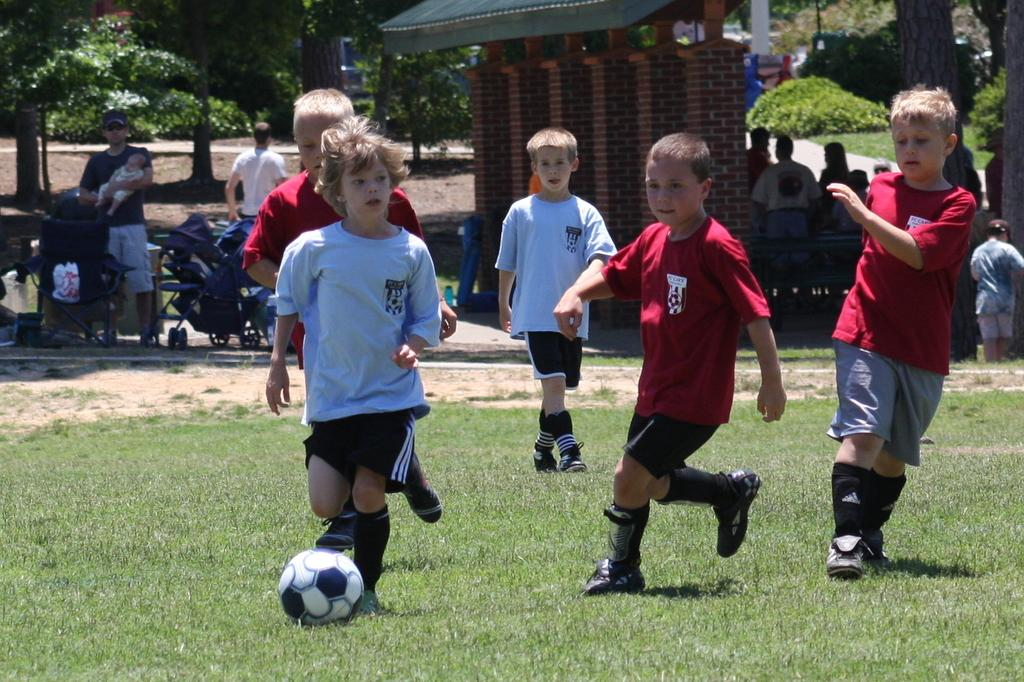What activity are the children engaged in on the ground? The children are playing football on the ground. Can you describe the scene in the background? In the background, there is a person holding a baby, additional people standing, trees, a sun shade, and a path. What type of surface are the children playing on? The children are playing on grass. What is the weather like in the image? The presence of a sun shade and clear visibility of the scene suggests that it is a sunny day. Can you hear the hen clucking in the image? There is no hen present in the image, so it is not possible to hear any clucking. What is the chance of thunder occurring in the image? There is no indication of thunder or any related weather conditions in the image. 